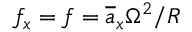Convert formula to latex. <formula><loc_0><loc_0><loc_500><loc_500>f _ { x } = f = \overline { a } _ { x } \Omega ^ { 2 } / R</formula> 